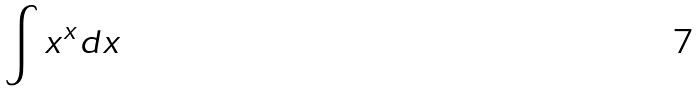Convert formula to latex. <formula><loc_0><loc_0><loc_500><loc_500>\int x ^ { x } d x</formula> 